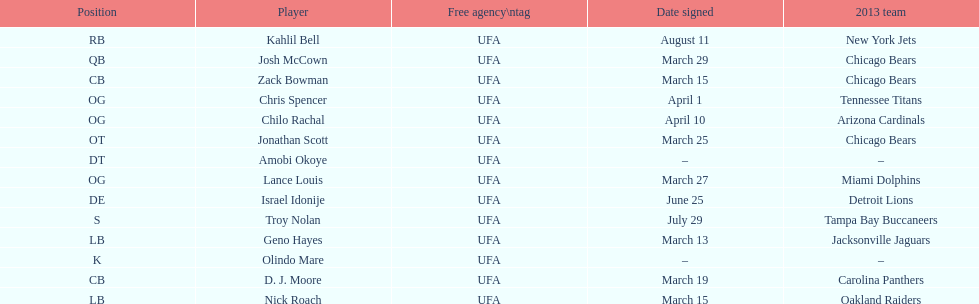How many players play cb or og? 5. 